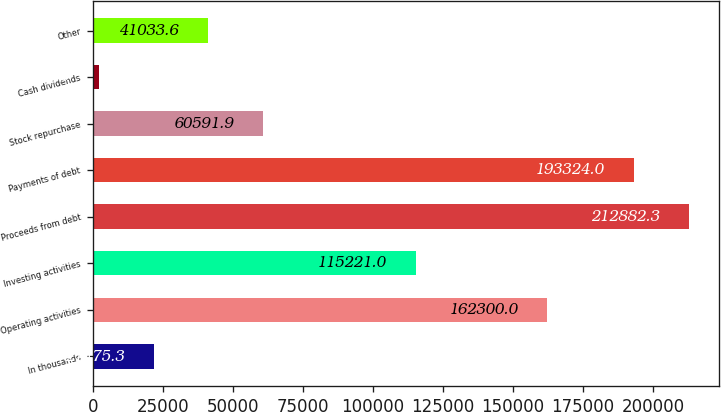Convert chart. <chart><loc_0><loc_0><loc_500><loc_500><bar_chart><fcel>In thousands<fcel>Operating activities<fcel>Investing activities<fcel>Proceeds from debt<fcel>Payments of debt<fcel>Stock repurchase<fcel>Cash dividends<fcel>Other<nl><fcel>21475.3<fcel>162300<fcel>115221<fcel>212882<fcel>193324<fcel>60591.9<fcel>1917<fcel>41033.6<nl></chart> 